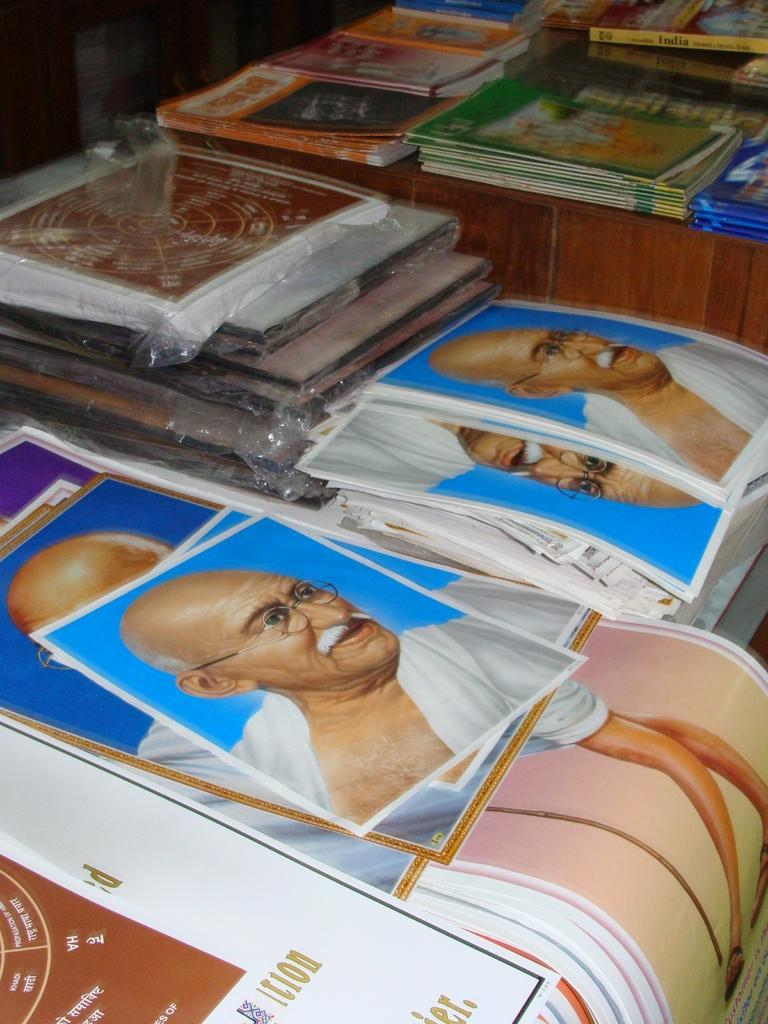What is depicted on the posters in the image? There are posters with the picture of Mahatma Gandhi in the image. What else can be seen in the image besides the posters? There are books in the image. Where are the books placed? The books are placed on a wooden table. What historical event is the queen celebrating in the image? There is no queen or historical event present in the image; it features posters with Mahatma Gandhi's picture and books on a wooden table. 